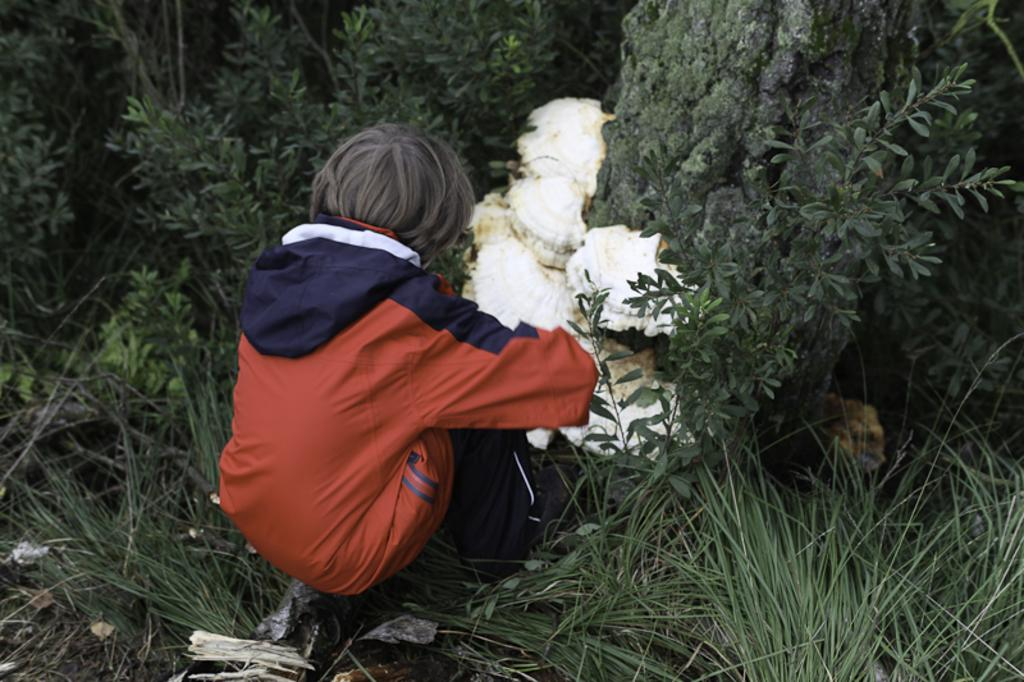Who or what is present in the image? There is a person in the image. What is the person's location in relation to the plants? The person is near plants. What type of ground is visible at the bottom of the image? There is grass visible at the bottom of the image. What is the color and location of the object in the middle of the image? There is a white color object in the middle of the image. What type of cracker is being used to paint the office in the image? There is no cracker or painting activity present in the image. The image features a person near plants, grass, and a white object in the middle. 